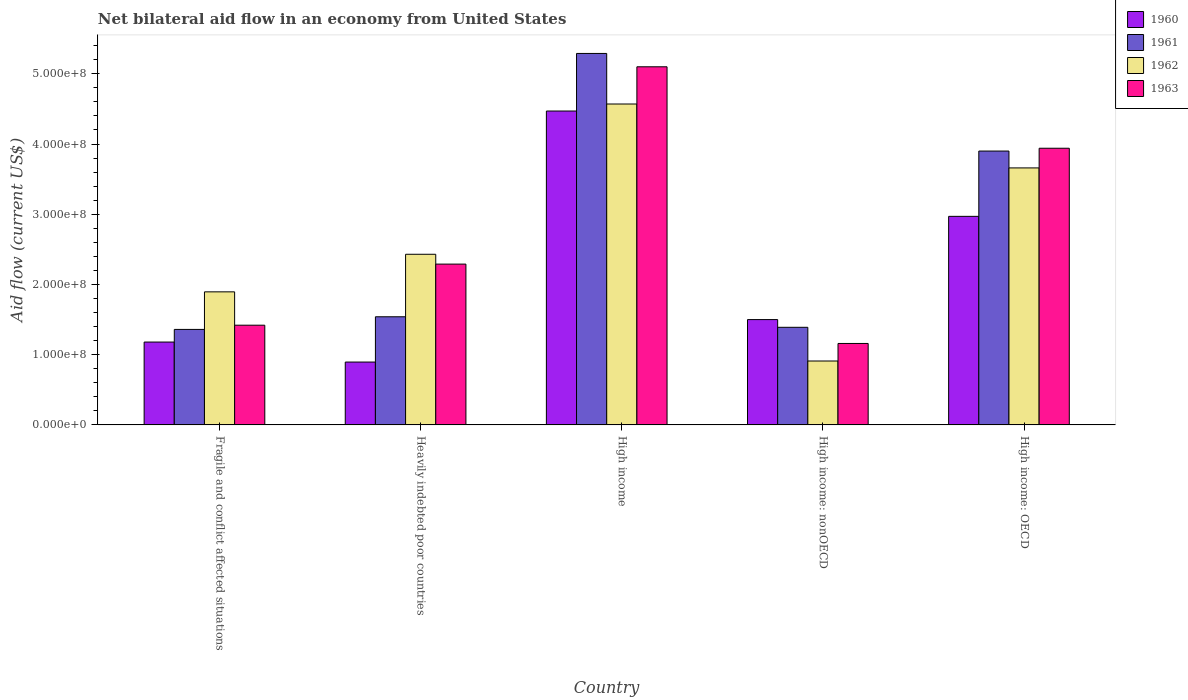How many different coloured bars are there?
Your answer should be compact. 4. How many groups of bars are there?
Keep it short and to the point. 5. How many bars are there on the 2nd tick from the left?
Offer a terse response. 4. How many bars are there on the 2nd tick from the right?
Your answer should be very brief. 4. What is the label of the 1st group of bars from the left?
Offer a very short reply. Fragile and conflict affected situations. What is the net bilateral aid flow in 1963 in High income?
Offer a very short reply. 5.10e+08. Across all countries, what is the maximum net bilateral aid flow in 1960?
Provide a succinct answer. 4.47e+08. Across all countries, what is the minimum net bilateral aid flow in 1961?
Provide a succinct answer. 1.36e+08. In which country was the net bilateral aid flow in 1960 minimum?
Your answer should be very brief. Heavily indebted poor countries. What is the total net bilateral aid flow in 1961 in the graph?
Your answer should be very brief. 1.35e+09. What is the difference between the net bilateral aid flow in 1961 in High income and that in High income: nonOECD?
Provide a short and direct response. 3.90e+08. What is the difference between the net bilateral aid flow in 1963 in High income: nonOECD and the net bilateral aid flow in 1962 in High income: OECD?
Ensure brevity in your answer.  -2.50e+08. What is the average net bilateral aid flow in 1962 per country?
Keep it short and to the point. 2.69e+08. What is the difference between the net bilateral aid flow of/in 1960 and net bilateral aid flow of/in 1961 in High income: nonOECD?
Provide a succinct answer. 1.10e+07. In how many countries, is the net bilateral aid flow in 1963 greater than 420000000 US$?
Your answer should be very brief. 1. What is the ratio of the net bilateral aid flow in 1961 in High income to that in High income: nonOECD?
Offer a very short reply. 3.81. What is the difference between the highest and the second highest net bilateral aid flow in 1961?
Provide a succinct answer. 3.75e+08. What is the difference between the highest and the lowest net bilateral aid flow in 1961?
Ensure brevity in your answer.  3.93e+08. Is the sum of the net bilateral aid flow in 1961 in Heavily indebted poor countries and High income greater than the maximum net bilateral aid flow in 1962 across all countries?
Provide a short and direct response. Yes. Is it the case that in every country, the sum of the net bilateral aid flow in 1963 and net bilateral aid flow in 1961 is greater than the sum of net bilateral aid flow in 1960 and net bilateral aid flow in 1962?
Offer a terse response. No. Is it the case that in every country, the sum of the net bilateral aid flow in 1962 and net bilateral aid flow in 1960 is greater than the net bilateral aid flow in 1963?
Your answer should be compact. Yes. How many bars are there?
Give a very brief answer. 20. Are all the bars in the graph horizontal?
Your response must be concise. No. How many countries are there in the graph?
Make the answer very short. 5. How are the legend labels stacked?
Keep it short and to the point. Vertical. What is the title of the graph?
Your answer should be very brief. Net bilateral aid flow in an economy from United States. Does "1976" appear as one of the legend labels in the graph?
Your response must be concise. No. What is the Aid flow (current US$) of 1960 in Fragile and conflict affected situations?
Make the answer very short. 1.18e+08. What is the Aid flow (current US$) in 1961 in Fragile and conflict affected situations?
Your answer should be very brief. 1.36e+08. What is the Aid flow (current US$) of 1962 in Fragile and conflict affected situations?
Your response must be concise. 1.90e+08. What is the Aid flow (current US$) in 1963 in Fragile and conflict affected situations?
Ensure brevity in your answer.  1.42e+08. What is the Aid flow (current US$) in 1960 in Heavily indebted poor countries?
Give a very brief answer. 8.95e+07. What is the Aid flow (current US$) of 1961 in Heavily indebted poor countries?
Offer a terse response. 1.54e+08. What is the Aid flow (current US$) of 1962 in Heavily indebted poor countries?
Offer a very short reply. 2.43e+08. What is the Aid flow (current US$) in 1963 in Heavily indebted poor countries?
Your response must be concise. 2.29e+08. What is the Aid flow (current US$) in 1960 in High income?
Ensure brevity in your answer.  4.47e+08. What is the Aid flow (current US$) in 1961 in High income?
Give a very brief answer. 5.29e+08. What is the Aid flow (current US$) in 1962 in High income?
Give a very brief answer. 4.57e+08. What is the Aid flow (current US$) of 1963 in High income?
Your answer should be very brief. 5.10e+08. What is the Aid flow (current US$) of 1960 in High income: nonOECD?
Offer a terse response. 1.50e+08. What is the Aid flow (current US$) in 1961 in High income: nonOECD?
Your answer should be very brief. 1.39e+08. What is the Aid flow (current US$) of 1962 in High income: nonOECD?
Keep it short and to the point. 9.10e+07. What is the Aid flow (current US$) in 1963 in High income: nonOECD?
Offer a terse response. 1.16e+08. What is the Aid flow (current US$) of 1960 in High income: OECD?
Your answer should be compact. 2.97e+08. What is the Aid flow (current US$) in 1961 in High income: OECD?
Your answer should be compact. 3.90e+08. What is the Aid flow (current US$) of 1962 in High income: OECD?
Make the answer very short. 3.66e+08. What is the Aid flow (current US$) of 1963 in High income: OECD?
Keep it short and to the point. 3.94e+08. Across all countries, what is the maximum Aid flow (current US$) in 1960?
Keep it short and to the point. 4.47e+08. Across all countries, what is the maximum Aid flow (current US$) of 1961?
Your answer should be very brief. 5.29e+08. Across all countries, what is the maximum Aid flow (current US$) of 1962?
Keep it short and to the point. 4.57e+08. Across all countries, what is the maximum Aid flow (current US$) of 1963?
Offer a terse response. 5.10e+08. Across all countries, what is the minimum Aid flow (current US$) in 1960?
Make the answer very short. 8.95e+07. Across all countries, what is the minimum Aid flow (current US$) of 1961?
Give a very brief answer. 1.36e+08. Across all countries, what is the minimum Aid flow (current US$) of 1962?
Ensure brevity in your answer.  9.10e+07. Across all countries, what is the minimum Aid flow (current US$) of 1963?
Give a very brief answer. 1.16e+08. What is the total Aid flow (current US$) in 1960 in the graph?
Ensure brevity in your answer.  1.10e+09. What is the total Aid flow (current US$) in 1961 in the graph?
Give a very brief answer. 1.35e+09. What is the total Aid flow (current US$) in 1962 in the graph?
Ensure brevity in your answer.  1.35e+09. What is the total Aid flow (current US$) of 1963 in the graph?
Your response must be concise. 1.39e+09. What is the difference between the Aid flow (current US$) of 1960 in Fragile and conflict affected situations and that in Heavily indebted poor countries?
Offer a very short reply. 2.85e+07. What is the difference between the Aid flow (current US$) of 1961 in Fragile and conflict affected situations and that in Heavily indebted poor countries?
Provide a short and direct response. -1.80e+07. What is the difference between the Aid flow (current US$) in 1962 in Fragile and conflict affected situations and that in Heavily indebted poor countries?
Ensure brevity in your answer.  -5.35e+07. What is the difference between the Aid flow (current US$) in 1963 in Fragile and conflict affected situations and that in Heavily indebted poor countries?
Provide a short and direct response. -8.70e+07. What is the difference between the Aid flow (current US$) in 1960 in Fragile and conflict affected situations and that in High income?
Give a very brief answer. -3.29e+08. What is the difference between the Aid flow (current US$) in 1961 in Fragile and conflict affected situations and that in High income?
Make the answer very short. -3.93e+08. What is the difference between the Aid flow (current US$) in 1962 in Fragile and conflict affected situations and that in High income?
Your answer should be very brief. -2.68e+08. What is the difference between the Aid flow (current US$) of 1963 in Fragile and conflict affected situations and that in High income?
Give a very brief answer. -3.68e+08. What is the difference between the Aid flow (current US$) of 1960 in Fragile and conflict affected situations and that in High income: nonOECD?
Keep it short and to the point. -3.20e+07. What is the difference between the Aid flow (current US$) in 1961 in Fragile and conflict affected situations and that in High income: nonOECD?
Make the answer very short. -3.00e+06. What is the difference between the Aid flow (current US$) of 1962 in Fragile and conflict affected situations and that in High income: nonOECD?
Provide a short and direct response. 9.85e+07. What is the difference between the Aid flow (current US$) in 1963 in Fragile and conflict affected situations and that in High income: nonOECD?
Your answer should be very brief. 2.60e+07. What is the difference between the Aid flow (current US$) in 1960 in Fragile and conflict affected situations and that in High income: OECD?
Ensure brevity in your answer.  -1.79e+08. What is the difference between the Aid flow (current US$) in 1961 in Fragile and conflict affected situations and that in High income: OECD?
Ensure brevity in your answer.  -2.54e+08. What is the difference between the Aid flow (current US$) in 1962 in Fragile and conflict affected situations and that in High income: OECD?
Make the answer very short. -1.76e+08. What is the difference between the Aid flow (current US$) of 1963 in Fragile and conflict affected situations and that in High income: OECD?
Give a very brief answer. -2.52e+08. What is the difference between the Aid flow (current US$) in 1960 in Heavily indebted poor countries and that in High income?
Provide a succinct answer. -3.57e+08. What is the difference between the Aid flow (current US$) of 1961 in Heavily indebted poor countries and that in High income?
Your answer should be compact. -3.75e+08. What is the difference between the Aid flow (current US$) of 1962 in Heavily indebted poor countries and that in High income?
Provide a short and direct response. -2.14e+08. What is the difference between the Aid flow (current US$) of 1963 in Heavily indebted poor countries and that in High income?
Provide a short and direct response. -2.81e+08. What is the difference between the Aid flow (current US$) in 1960 in Heavily indebted poor countries and that in High income: nonOECD?
Keep it short and to the point. -6.05e+07. What is the difference between the Aid flow (current US$) in 1961 in Heavily indebted poor countries and that in High income: nonOECD?
Provide a succinct answer. 1.50e+07. What is the difference between the Aid flow (current US$) of 1962 in Heavily indebted poor countries and that in High income: nonOECD?
Offer a terse response. 1.52e+08. What is the difference between the Aid flow (current US$) of 1963 in Heavily indebted poor countries and that in High income: nonOECD?
Provide a succinct answer. 1.13e+08. What is the difference between the Aid flow (current US$) in 1960 in Heavily indebted poor countries and that in High income: OECD?
Offer a terse response. -2.07e+08. What is the difference between the Aid flow (current US$) in 1961 in Heavily indebted poor countries and that in High income: OECD?
Your response must be concise. -2.36e+08. What is the difference between the Aid flow (current US$) of 1962 in Heavily indebted poor countries and that in High income: OECD?
Offer a very short reply. -1.23e+08. What is the difference between the Aid flow (current US$) of 1963 in Heavily indebted poor countries and that in High income: OECD?
Keep it short and to the point. -1.65e+08. What is the difference between the Aid flow (current US$) in 1960 in High income and that in High income: nonOECD?
Your answer should be very brief. 2.97e+08. What is the difference between the Aid flow (current US$) of 1961 in High income and that in High income: nonOECD?
Provide a succinct answer. 3.90e+08. What is the difference between the Aid flow (current US$) of 1962 in High income and that in High income: nonOECD?
Make the answer very short. 3.66e+08. What is the difference between the Aid flow (current US$) of 1963 in High income and that in High income: nonOECD?
Your answer should be very brief. 3.94e+08. What is the difference between the Aid flow (current US$) of 1960 in High income and that in High income: OECD?
Make the answer very short. 1.50e+08. What is the difference between the Aid flow (current US$) in 1961 in High income and that in High income: OECD?
Offer a very short reply. 1.39e+08. What is the difference between the Aid flow (current US$) of 1962 in High income and that in High income: OECD?
Keep it short and to the point. 9.10e+07. What is the difference between the Aid flow (current US$) in 1963 in High income and that in High income: OECD?
Provide a short and direct response. 1.16e+08. What is the difference between the Aid flow (current US$) in 1960 in High income: nonOECD and that in High income: OECD?
Your response must be concise. -1.47e+08. What is the difference between the Aid flow (current US$) of 1961 in High income: nonOECD and that in High income: OECD?
Provide a short and direct response. -2.51e+08. What is the difference between the Aid flow (current US$) in 1962 in High income: nonOECD and that in High income: OECD?
Ensure brevity in your answer.  -2.75e+08. What is the difference between the Aid flow (current US$) of 1963 in High income: nonOECD and that in High income: OECD?
Ensure brevity in your answer.  -2.78e+08. What is the difference between the Aid flow (current US$) of 1960 in Fragile and conflict affected situations and the Aid flow (current US$) of 1961 in Heavily indebted poor countries?
Keep it short and to the point. -3.60e+07. What is the difference between the Aid flow (current US$) of 1960 in Fragile and conflict affected situations and the Aid flow (current US$) of 1962 in Heavily indebted poor countries?
Provide a short and direct response. -1.25e+08. What is the difference between the Aid flow (current US$) in 1960 in Fragile and conflict affected situations and the Aid flow (current US$) in 1963 in Heavily indebted poor countries?
Offer a very short reply. -1.11e+08. What is the difference between the Aid flow (current US$) of 1961 in Fragile and conflict affected situations and the Aid flow (current US$) of 1962 in Heavily indebted poor countries?
Offer a very short reply. -1.07e+08. What is the difference between the Aid flow (current US$) of 1961 in Fragile and conflict affected situations and the Aid flow (current US$) of 1963 in Heavily indebted poor countries?
Offer a very short reply. -9.30e+07. What is the difference between the Aid flow (current US$) of 1962 in Fragile and conflict affected situations and the Aid flow (current US$) of 1963 in Heavily indebted poor countries?
Ensure brevity in your answer.  -3.95e+07. What is the difference between the Aid flow (current US$) in 1960 in Fragile and conflict affected situations and the Aid flow (current US$) in 1961 in High income?
Provide a short and direct response. -4.11e+08. What is the difference between the Aid flow (current US$) of 1960 in Fragile and conflict affected situations and the Aid flow (current US$) of 1962 in High income?
Keep it short and to the point. -3.39e+08. What is the difference between the Aid flow (current US$) in 1960 in Fragile and conflict affected situations and the Aid flow (current US$) in 1963 in High income?
Make the answer very short. -3.92e+08. What is the difference between the Aid flow (current US$) of 1961 in Fragile and conflict affected situations and the Aid flow (current US$) of 1962 in High income?
Make the answer very short. -3.21e+08. What is the difference between the Aid flow (current US$) in 1961 in Fragile and conflict affected situations and the Aid flow (current US$) in 1963 in High income?
Offer a terse response. -3.74e+08. What is the difference between the Aid flow (current US$) in 1962 in Fragile and conflict affected situations and the Aid flow (current US$) in 1963 in High income?
Make the answer very short. -3.20e+08. What is the difference between the Aid flow (current US$) of 1960 in Fragile and conflict affected situations and the Aid flow (current US$) of 1961 in High income: nonOECD?
Keep it short and to the point. -2.10e+07. What is the difference between the Aid flow (current US$) in 1960 in Fragile and conflict affected situations and the Aid flow (current US$) in 1962 in High income: nonOECD?
Provide a short and direct response. 2.70e+07. What is the difference between the Aid flow (current US$) in 1960 in Fragile and conflict affected situations and the Aid flow (current US$) in 1963 in High income: nonOECD?
Ensure brevity in your answer.  2.00e+06. What is the difference between the Aid flow (current US$) in 1961 in Fragile and conflict affected situations and the Aid flow (current US$) in 1962 in High income: nonOECD?
Make the answer very short. 4.50e+07. What is the difference between the Aid flow (current US$) of 1961 in Fragile and conflict affected situations and the Aid flow (current US$) of 1963 in High income: nonOECD?
Your answer should be compact. 2.00e+07. What is the difference between the Aid flow (current US$) of 1962 in Fragile and conflict affected situations and the Aid flow (current US$) of 1963 in High income: nonOECD?
Offer a very short reply. 7.35e+07. What is the difference between the Aid flow (current US$) of 1960 in Fragile and conflict affected situations and the Aid flow (current US$) of 1961 in High income: OECD?
Keep it short and to the point. -2.72e+08. What is the difference between the Aid flow (current US$) in 1960 in Fragile and conflict affected situations and the Aid flow (current US$) in 1962 in High income: OECD?
Provide a short and direct response. -2.48e+08. What is the difference between the Aid flow (current US$) of 1960 in Fragile and conflict affected situations and the Aid flow (current US$) of 1963 in High income: OECD?
Your response must be concise. -2.76e+08. What is the difference between the Aid flow (current US$) in 1961 in Fragile and conflict affected situations and the Aid flow (current US$) in 1962 in High income: OECD?
Your answer should be compact. -2.30e+08. What is the difference between the Aid flow (current US$) of 1961 in Fragile and conflict affected situations and the Aid flow (current US$) of 1963 in High income: OECD?
Make the answer very short. -2.58e+08. What is the difference between the Aid flow (current US$) in 1962 in Fragile and conflict affected situations and the Aid flow (current US$) in 1963 in High income: OECD?
Keep it short and to the point. -2.04e+08. What is the difference between the Aid flow (current US$) in 1960 in Heavily indebted poor countries and the Aid flow (current US$) in 1961 in High income?
Your answer should be very brief. -4.39e+08. What is the difference between the Aid flow (current US$) in 1960 in Heavily indebted poor countries and the Aid flow (current US$) in 1962 in High income?
Your response must be concise. -3.67e+08. What is the difference between the Aid flow (current US$) of 1960 in Heavily indebted poor countries and the Aid flow (current US$) of 1963 in High income?
Offer a terse response. -4.20e+08. What is the difference between the Aid flow (current US$) in 1961 in Heavily indebted poor countries and the Aid flow (current US$) in 1962 in High income?
Ensure brevity in your answer.  -3.03e+08. What is the difference between the Aid flow (current US$) in 1961 in Heavily indebted poor countries and the Aid flow (current US$) in 1963 in High income?
Your answer should be very brief. -3.56e+08. What is the difference between the Aid flow (current US$) of 1962 in Heavily indebted poor countries and the Aid flow (current US$) of 1963 in High income?
Give a very brief answer. -2.67e+08. What is the difference between the Aid flow (current US$) of 1960 in Heavily indebted poor countries and the Aid flow (current US$) of 1961 in High income: nonOECD?
Offer a terse response. -4.95e+07. What is the difference between the Aid flow (current US$) in 1960 in Heavily indebted poor countries and the Aid flow (current US$) in 1962 in High income: nonOECD?
Offer a very short reply. -1.48e+06. What is the difference between the Aid flow (current US$) in 1960 in Heavily indebted poor countries and the Aid flow (current US$) in 1963 in High income: nonOECD?
Ensure brevity in your answer.  -2.65e+07. What is the difference between the Aid flow (current US$) in 1961 in Heavily indebted poor countries and the Aid flow (current US$) in 1962 in High income: nonOECD?
Your response must be concise. 6.30e+07. What is the difference between the Aid flow (current US$) in 1961 in Heavily indebted poor countries and the Aid flow (current US$) in 1963 in High income: nonOECD?
Ensure brevity in your answer.  3.80e+07. What is the difference between the Aid flow (current US$) of 1962 in Heavily indebted poor countries and the Aid flow (current US$) of 1963 in High income: nonOECD?
Make the answer very short. 1.27e+08. What is the difference between the Aid flow (current US$) of 1960 in Heavily indebted poor countries and the Aid flow (current US$) of 1961 in High income: OECD?
Ensure brevity in your answer.  -3.00e+08. What is the difference between the Aid flow (current US$) of 1960 in Heavily indebted poor countries and the Aid flow (current US$) of 1962 in High income: OECD?
Your answer should be compact. -2.76e+08. What is the difference between the Aid flow (current US$) in 1960 in Heavily indebted poor countries and the Aid flow (current US$) in 1963 in High income: OECD?
Your answer should be very brief. -3.04e+08. What is the difference between the Aid flow (current US$) in 1961 in Heavily indebted poor countries and the Aid flow (current US$) in 1962 in High income: OECD?
Your response must be concise. -2.12e+08. What is the difference between the Aid flow (current US$) in 1961 in Heavily indebted poor countries and the Aid flow (current US$) in 1963 in High income: OECD?
Make the answer very short. -2.40e+08. What is the difference between the Aid flow (current US$) of 1962 in Heavily indebted poor countries and the Aid flow (current US$) of 1963 in High income: OECD?
Make the answer very short. -1.51e+08. What is the difference between the Aid flow (current US$) in 1960 in High income and the Aid flow (current US$) in 1961 in High income: nonOECD?
Your answer should be very brief. 3.08e+08. What is the difference between the Aid flow (current US$) in 1960 in High income and the Aid flow (current US$) in 1962 in High income: nonOECD?
Ensure brevity in your answer.  3.56e+08. What is the difference between the Aid flow (current US$) in 1960 in High income and the Aid flow (current US$) in 1963 in High income: nonOECD?
Provide a succinct answer. 3.31e+08. What is the difference between the Aid flow (current US$) of 1961 in High income and the Aid flow (current US$) of 1962 in High income: nonOECD?
Provide a succinct answer. 4.38e+08. What is the difference between the Aid flow (current US$) of 1961 in High income and the Aid flow (current US$) of 1963 in High income: nonOECD?
Your answer should be very brief. 4.13e+08. What is the difference between the Aid flow (current US$) in 1962 in High income and the Aid flow (current US$) in 1963 in High income: nonOECD?
Make the answer very short. 3.41e+08. What is the difference between the Aid flow (current US$) in 1960 in High income and the Aid flow (current US$) in 1961 in High income: OECD?
Give a very brief answer. 5.70e+07. What is the difference between the Aid flow (current US$) of 1960 in High income and the Aid flow (current US$) of 1962 in High income: OECD?
Your answer should be compact. 8.10e+07. What is the difference between the Aid flow (current US$) of 1960 in High income and the Aid flow (current US$) of 1963 in High income: OECD?
Offer a very short reply. 5.30e+07. What is the difference between the Aid flow (current US$) of 1961 in High income and the Aid flow (current US$) of 1962 in High income: OECD?
Your answer should be very brief. 1.63e+08. What is the difference between the Aid flow (current US$) of 1961 in High income and the Aid flow (current US$) of 1963 in High income: OECD?
Your answer should be very brief. 1.35e+08. What is the difference between the Aid flow (current US$) of 1962 in High income and the Aid flow (current US$) of 1963 in High income: OECD?
Your response must be concise. 6.30e+07. What is the difference between the Aid flow (current US$) of 1960 in High income: nonOECD and the Aid flow (current US$) of 1961 in High income: OECD?
Offer a terse response. -2.40e+08. What is the difference between the Aid flow (current US$) of 1960 in High income: nonOECD and the Aid flow (current US$) of 1962 in High income: OECD?
Provide a succinct answer. -2.16e+08. What is the difference between the Aid flow (current US$) of 1960 in High income: nonOECD and the Aid flow (current US$) of 1963 in High income: OECD?
Give a very brief answer. -2.44e+08. What is the difference between the Aid flow (current US$) of 1961 in High income: nonOECD and the Aid flow (current US$) of 1962 in High income: OECD?
Keep it short and to the point. -2.27e+08. What is the difference between the Aid flow (current US$) in 1961 in High income: nonOECD and the Aid flow (current US$) in 1963 in High income: OECD?
Your response must be concise. -2.55e+08. What is the difference between the Aid flow (current US$) of 1962 in High income: nonOECD and the Aid flow (current US$) of 1963 in High income: OECD?
Your answer should be compact. -3.03e+08. What is the average Aid flow (current US$) of 1960 per country?
Provide a short and direct response. 2.20e+08. What is the average Aid flow (current US$) in 1961 per country?
Your response must be concise. 2.70e+08. What is the average Aid flow (current US$) of 1962 per country?
Provide a succinct answer. 2.69e+08. What is the average Aid flow (current US$) in 1963 per country?
Keep it short and to the point. 2.78e+08. What is the difference between the Aid flow (current US$) of 1960 and Aid flow (current US$) of 1961 in Fragile and conflict affected situations?
Ensure brevity in your answer.  -1.80e+07. What is the difference between the Aid flow (current US$) of 1960 and Aid flow (current US$) of 1962 in Fragile and conflict affected situations?
Your answer should be compact. -7.15e+07. What is the difference between the Aid flow (current US$) in 1960 and Aid flow (current US$) in 1963 in Fragile and conflict affected situations?
Your response must be concise. -2.40e+07. What is the difference between the Aid flow (current US$) in 1961 and Aid flow (current US$) in 1962 in Fragile and conflict affected situations?
Provide a short and direct response. -5.35e+07. What is the difference between the Aid flow (current US$) in 1961 and Aid flow (current US$) in 1963 in Fragile and conflict affected situations?
Make the answer very short. -6.00e+06. What is the difference between the Aid flow (current US$) of 1962 and Aid flow (current US$) of 1963 in Fragile and conflict affected situations?
Offer a very short reply. 4.75e+07. What is the difference between the Aid flow (current US$) of 1960 and Aid flow (current US$) of 1961 in Heavily indebted poor countries?
Offer a very short reply. -6.45e+07. What is the difference between the Aid flow (current US$) of 1960 and Aid flow (current US$) of 1962 in Heavily indebted poor countries?
Your answer should be very brief. -1.53e+08. What is the difference between the Aid flow (current US$) of 1960 and Aid flow (current US$) of 1963 in Heavily indebted poor countries?
Keep it short and to the point. -1.39e+08. What is the difference between the Aid flow (current US$) of 1961 and Aid flow (current US$) of 1962 in Heavily indebted poor countries?
Your answer should be very brief. -8.90e+07. What is the difference between the Aid flow (current US$) in 1961 and Aid flow (current US$) in 1963 in Heavily indebted poor countries?
Offer a terse response. -7.50e+07. What is the difference between the Aid flow (current US$) in 1962 and Aid flow (current US$) in 1963 in Heavily indebted poor countries?
Keep it short and to the point. 1.40e+07. What is the difference between the Aid flow (current US$) of 1960 and Aid flow (current US$) of 1961 in High income?
Make the answer very short. -8.20e+07. What is the difference between the Aid flow (current US$) in 1960 and Aid flow (current US$) in 1962 in High income?
Provide a short and direct response. -1.00e+07. What is the difference between the Aid flow (current US$) in 1960 and Aid flow (current US$) in 1963 in High income?
Provide a succinct answer. -6.30e+07. What is the difference between the Aid flow (current US$) of 1961 and Aid flow (current US$) of 1962 in High income?
Provide a succinct answer. 7.20e+07. What is the difference between the Aid flow (current US$) of 1961 and Aid flow (current US$) of 1963 in High income?
Ensure brevity in your answer.  1.90e+07. What is the difference between the Aid flow (current US$) of 1962 and Aid flow (current US$) of 1963 in High income?
Your response must be concise. -5.30e+07. What is the difference between the Aid flow (current US$) of 1960 and Aid flow (current US$) of 1961 in High income: nonOECD?
Offer a terse response. 1.10e+07. What is the difference between the Aid flow (current US$) in 1960 and Aid flow (current US$) in 1962 in High income: nonOECD?
Your response must be concise. 5.90e+07. What is the difference between the Aid flow (current US$) of 1960 and Aid flow (current US$) of 1963 in High income: nonOECD?
Provide a succinct answer. 3.40e+07. What is the difference between the Aid flow (current US$) in 1961 and Aid flow (current US$) in 1962 in High income: nonOECD?
Keep it short and to the point. 4.80e+07. What is the difference between the Aid flow (current US$) of 1961 and Aid flow (current US$) of 1963 in High income: nonOECD?
Offer a terse response. 2.30e+07. What is the difference between the Aid flow (current US$) of 1962 and Aid flow (current US$) of 1963 in High income: nonOECD?
Keep it short and to the point. -2.50e+07. What is the difference between the Aid flow (current US$) of 1960 and Aid flow (current US$) of 1961 in High income: OECD?
Your answer should be very brief. -9.30e+07. What is the difference between the Aid flow (current US$) of 1960 and Aid flow (current US$) of 1962 in High income: OECD?
Your answer should be very brief. -6.90e+07. What is the difference between the Aid flow (current US$) of 1960 and Aid flow (current US$) of 1963 in High income: OECD?
Ensure brevity in your answer.  -9.70e+07. What is the difference between the Aid flow (current US$) in 1961 and Aid flow (current US$) in 1962 in High income: OECD?
Ensure brevity in your answer.  2.40e+07. What is the difference between the Aid flow (current US$) in 1961 and Aid flow (current US$) in 1963 in High income: OECD?
Your answer should be compact. -4.00e+06. What is the difference between the Aid flow (current US$) of 1962 and Aid flow (current US$) of 1963 in High income: OECD?
Offer a terse response. -2.80e+07. What is the ratio of the Aid flow (current US$) in 1960 in Fragile and conflict affected situations to that in Heavily indebted poor countries?
Make the answer very short. 1.32. What is the ratio of the Aid flow (current US$) in 1961 in Fragile and conflict affected situations to that in Heavily indebted poor countries?
Your answer should be compact. 0.88. What is the ratio of the Aid flow (current US$) of 1962 in Fragile and conflict affected situations to that in Heavily indebted poor countries?
Give a very brief answer. 0.78. What is the ratio of the Aid flow (current US$) in 1963 in Fragile and conflict affected situations to that in Heavily indebted poor countries?
Provide a succinct answer. 0.62. What is the ratio of the Aid flow (current US$) of 1960 in Fragile and conflict affected situations to that in High income?
Offer a terse response. 0.26. What is the ratio of the Aid flow (current US$) in 1961 in Fragile and conflict affected situations to that in High income?
Your answer should be compact. 0.26. What is the ratio of the Aid flow (current US$) of 1962 in Fragile and conflict affected situations to that in High income?
Ensure brevity in your answer.  0.41. What is the ratio of the Aid flow (current US$) of 1963 in Fragile and conflict affected situations to that in High income?
Give a very brief answer. 0.28. What is the ratio of the Aid flow (current US$) of 1960 in Fragile and conflict affected situations to that in High income: nonOECD?
Offer a terse response. 0.79. What is the ratio of the Aid flow (current US$) in 1961 in Fragile and conflict affected situations to that in High income: nonOECD?
Provide a short and direct response. 0.98. What is the ratio of the Aid flow (current US$) in 1962 in Fragile and conflict affected situations to that in High income: nonOECD?
Offer a terse response. 2.08. What is the ratio of the Aid flow (current US$) of 1963 in Fragile and conflict affected situations to that in High income: nonOECD?
Provide a succinct answer. 1.22. What is the ratio of the Aid flow (current US$) in 1960 in Fragile and conflict affected situations to that in High income: OECD?
Your answer should be very brief. 0.4. What is the ratio of the Aid flow (current US$) of 1961 in Fragile and conflict affected situations to that in High income: OECD?
Your response must be concise. 0.35. What is the ratio of the Aid flow (current US$) of 1962 in Fragile and conflict affected situations to that in High income: OECD?
Your response must be concise. 0.52. What is the ratio of the Aid flow (current US$) of 1963 in Fragile and conflict affected situations to that in High income: OECD?
Offer a very short reply. 0.36. What is the ratio of the Aid flow (current US$) in 1960 in Heavily indebted poor countries to that in High income?
Your response must be concise. 0.2. What is the ratio of the Aid flow (current US$) of 1961 in Heavily indebted poor countries to that in High income?
Provide a succinct answer. 0.29. What is the ratio of the Aid flow (current US$) in 1962 in Heavily indebted poor countries to that in High income?
Offer a very short reply. 0.53. What is the ratio of the Aid flow (current US$) of 1963 in Heavily indebted poor countries to that in High income?
Your answer should be compact. 0.45. What is the ratio of the Aid flow (current US$) in 1960 in Heavily indebted poor countries to that in High income: nonOECD?
Your answer should be compact. 0.6. What is the ratio of the Aid flow (current US$) of 1961 in Heavily indebted poor countries to that in High income: nonOECD?
Make the answer very short. 1.11. What is the ratio of the Aid flow (current US$) in 1962 in Heavily indebted poor countries to that in High income: nonOECD?
Your answer should be very brief. 2.67. What is the ratio of the Aid flow (current US$) of 1963 in Heavily indebted poor countries to that in High income: nonOECD?
Make the answer very short. 1.97. What is the ratio of the Aid flow (current US$) in 1960 in Heavily indebted poor countries to that in High income: OECD?
Provide a short and direct response. 0.3. What is the ratio of the Aid flow (current US$) of 1961 in Heavily indebted poor countries to that in High income: OECD?
Keep it short and to the point. 0.39. What is the ratio of the Aid flow (current US$) of 1962 in Heavily indebted poor countries to that in High income: OECD?
Ensure brevity in your answer.  0.66. What is the ratio of the Aid flow (current US$) of 1963 in Heavily indebted poor countries to that in High income: OECD?
Keep it short and to the point. 0.58. What is the ratio of the Aid flow (current US$) in 1960 in High income to that in High income: nonOECD?
Offer a terse response. 2.98. What is the ratio of the Aid flow (current US$) in 1961 in High income to that in High income: nonOECD?
Provide a short and direct response. 3.81. What is the ratio of the Aid flow (current US$) in 1962 in High income to that in High income: nonOECD?
Give a very brief answer. 5.02. What is the ratio of the Aid flow (current US$) of 1963 in High income to that in High income: nonOECD?
Make the answer very short. 4.4. What is the ratio of the Aid flow (current US$) of 1960 in High income to that in High income: OECD?
Your answer should be compact. 1.51. What is the ratio of the Aid flow (current US$) in 1961 in High income to that in High income: OECD?
Provide a short and direct response. 1.36. What is the ratio of the Aid flow (current US$) in 1962 in High income to that in High income: OECD?
Ensure brevity in your answer.  1.25. What is the ratio of the Aid flow (current US$) of 1963 in High income to that in High income: OECD?
Your response must be concise. 1.29. What is the ratio of the Aid flow (current US$) of 1960 in High income: nonOECD to that in High income: OECD?
Your answer should be very brief. 0.51. What is the ratio of the Aid flow (current US$) of 1961 in High income: nonOECD to that in High income: OECD?
Your answer should be compact. 0.36. What is the ratio of the Aid flow (current US$) in 1962 in High income: nonOECD to that in High income: OECD?
Keep it short and to the point. 0.25. What is the ratio of the Aid flow (current US$) of 1963 in High income: nonOECD to that in High income: OECD?
Offer a terse response. 0.29. What is the difference between the highest and the second highest Aid flow (current US$) of 1960?
Your answer should be compact. 1.50e+08. What is the difference between the highest and the second highest Aid flow (current US$) in 1961?
Make the answer very short. 1.39e+08. What is the difference between the highest and the second highest Aid flow (current US$) of 1962?
Offer a terse response. 9.10e+07. What is the difference between the highest and the second highest Aid flow (current US$) in 1963?
Provide a succinct answer. 1.16e+08. What is the difference between the highest and the lowest Aid flow (current US$) in 1960?
Make the answer very short. 3.57e+08. What is the difference between the highest and the lowest Aid flow (current US$) in 1961?
Give a very brief answer. 3.93e+08. What is the difference between the highest and the lowest Aid flow (current US$) of 1962?
Your answer should be compact. 3.66e+08. What is the difference between the highest and the lowest Aid flow (current US$) of 1963?
Provide a short and direct response. 3.94e+08. 